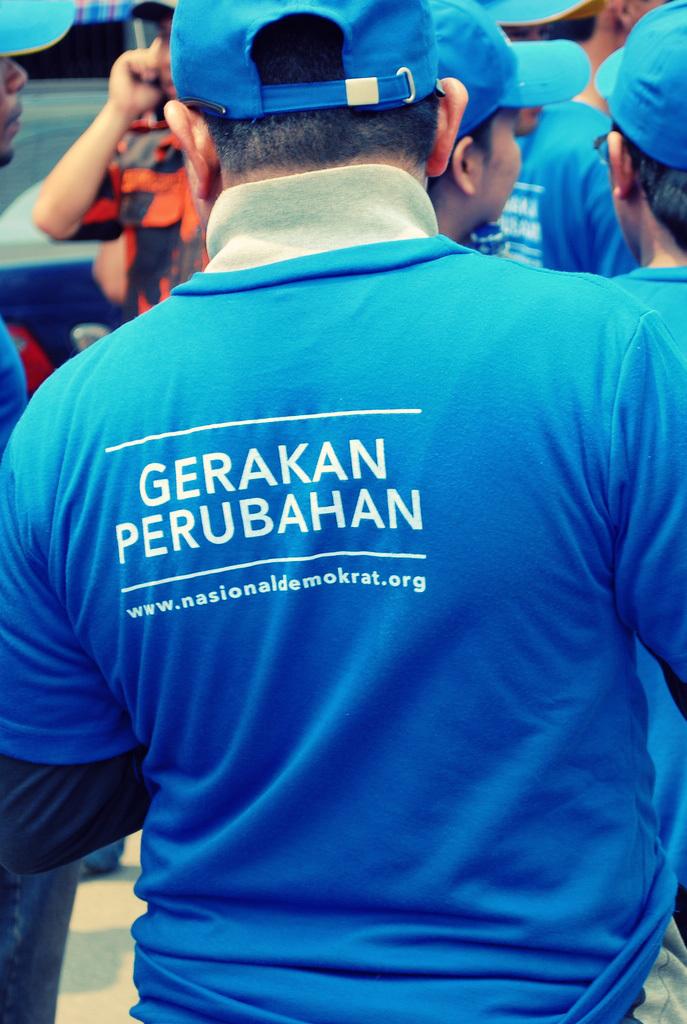What is the name of the company?
Ensure brevity in your answer.  Gerakan perubahan. 